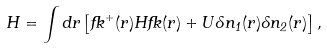<formula> <loc_0><loc_0><loc_500><loc_500>H = \int d { r } \left [ { \Psi } ^ { + } ( { r } ) H { \Psi } ( { r } ) + U \delta n _ { 1 } ( { r } ) \delta n _ { 2 } ( { r } ) \right ] ,</formula> 